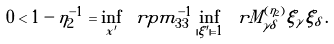Convert formula to latex. <formula><loc_0><loc_0><loc_500><loc_500>0 < 1 - \eta _ { 2 } ^ { - 1 } = \inf _ { x ^ { \prime } } \ r p m _ { 3 3 } ^ { - 1 } \inf _ { | \xi ^ { \prime } | = 1 } \ r M ^ { ( \eta _ { 2 } ) } _ { \gamma \delta } \xi _ { \gamma } \xi _ { \delta } \, .</formula> 